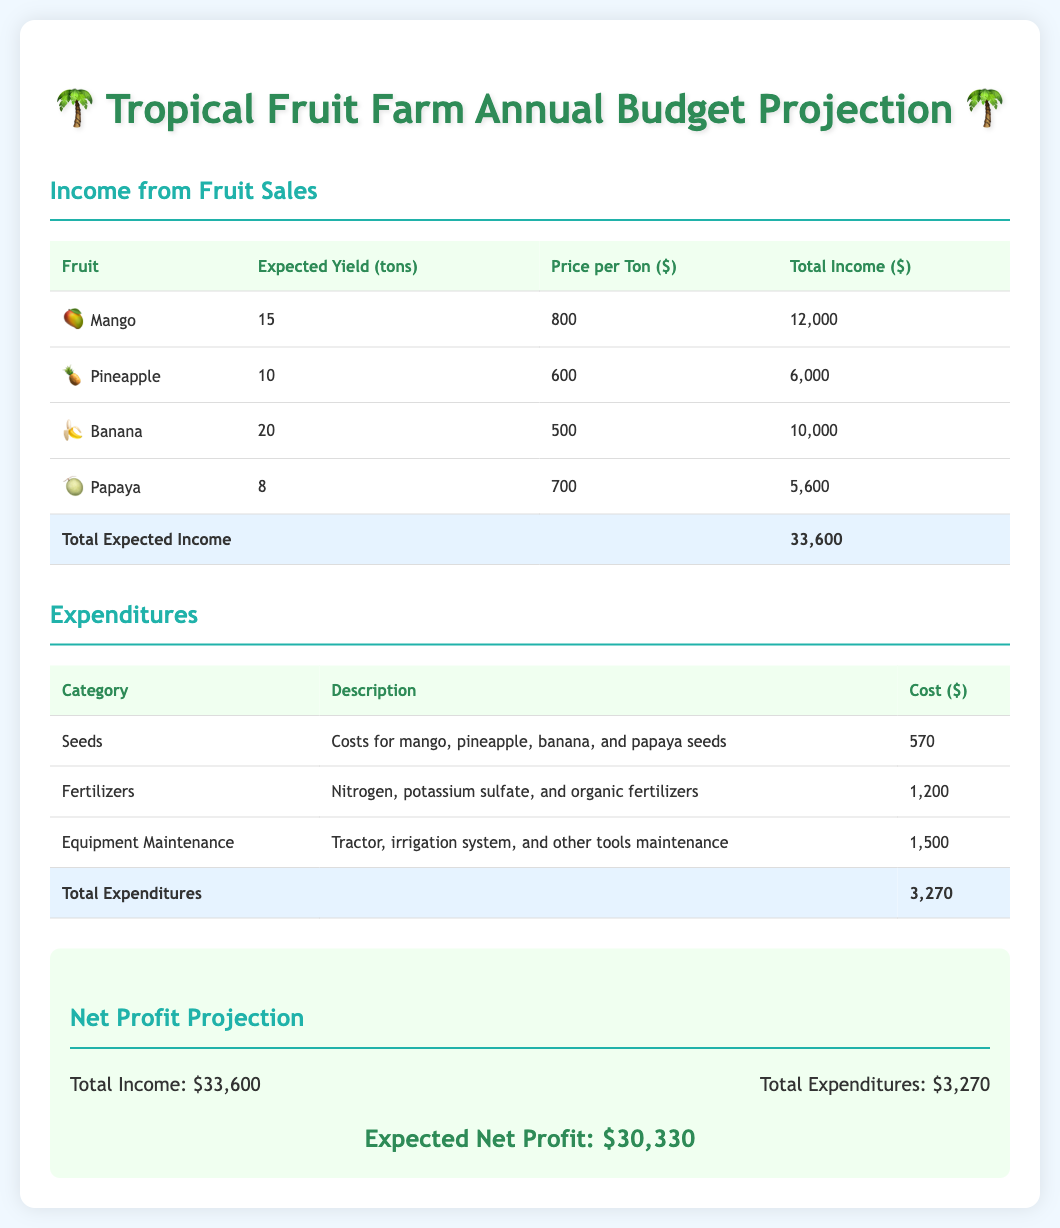What is the expected yield of mango? The expected yield of mango is listed in the document under the income section, which states it is 15 tons.
Answer: 15 tons What is the price per ton for pineapple? The price per ton for pineapple is mentioned in the income section, which is $600.
Answer: $600 What are the total expected expenditures? The total expected expenditures can be found in the expenditures table, and it sums up to $3,270.
Answer: $3,270 What is the total expected income from fruit sales? The total expected income from fruit sales is indicated in the income section, totaling $33,600.
Answer: $33,600 What is the net profit projection? The net profit projection is calculated in the profit section of the document, which amounts to $30,330.
Answer: $30,330 What are the types of seeds included in the expenditures? The expenditures section mentions seeds for mango, pineapple, banana, and papaya as the types of seeds included.
Answer: Mango, pineapple, banana, and papaya How much is allocated for fertilizers? The document specifies an allocation of $1,200 for fertilizers in the expenditures table.
Answer: $1,200 How does the expected income compare to expenses? The comparison shows that the total expected income of $33,600 significantly exceeds the total expenditures of $3,270.
Answer: Significantly exceeds What is the main purpose of this document? The main purpose of the document is to project the annual budget for the tropical fruit farm.
Answer: Project the annual budget 